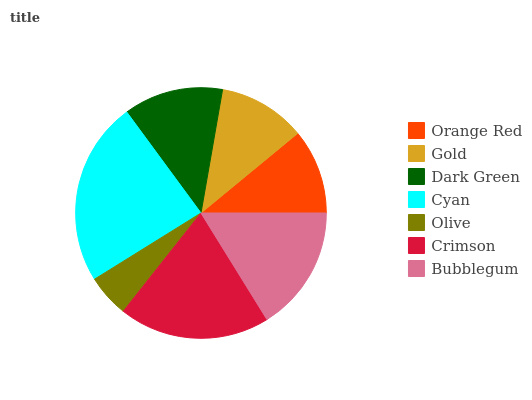Is Olive the minimum?
Answer yes or no. Yes. Is Cyan the maximum?
Answer yes or no. Yes. Is Gold the minimum?
Answer yes or no. No. Is Gold the maximum?
Answer yes or no. No. Is Gold greater than Orange Red?
Answer yes or no. Yes. Is Orange Red less than Gold?
Answer yes or no. Yes. Is Orange Red greater than Gold?
Answer yes or no. No. Is Gold less than Orange Red?
Answer yes or no. No. Is Dark Green the high median?
Answer yes or no. Yes. Is Dark Green the low median?
Answer yes or no. Yes. Is Bubblegum the high median?
Answer yes or no. No. Is Gold the low median?
Answer yes or no. No. 